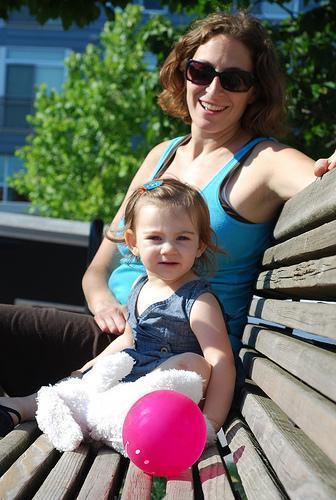How many people are sitting on the bench?
Give a very brief answer. 2. How many mothers are on the bench?
Give a very brief answer. 1. 